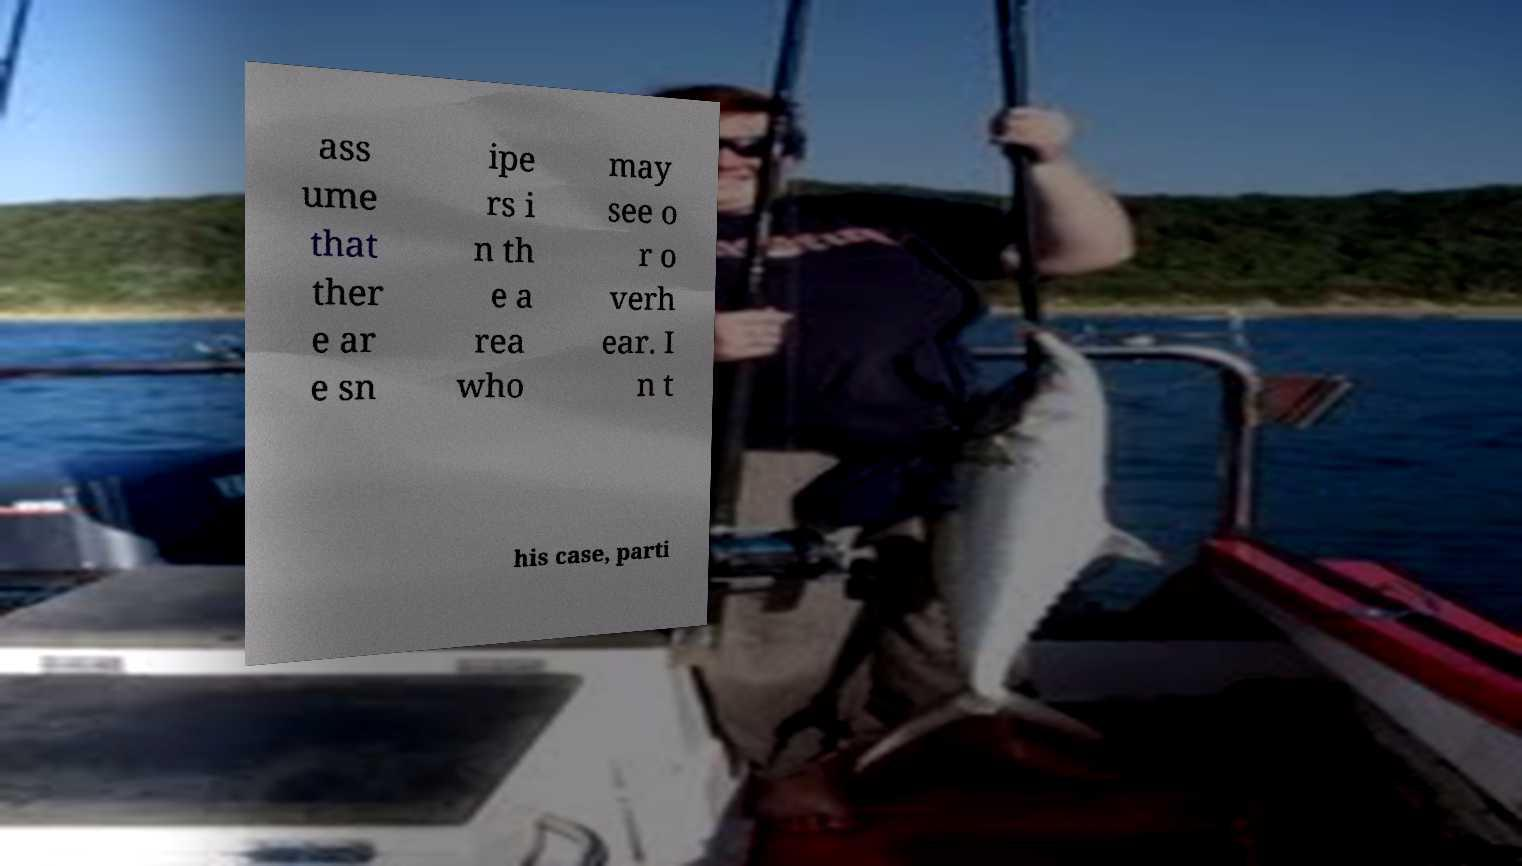I need the written content from this picture converted into text. Can you do that? ass ume that ther e ar e sn ipe rs i n th e a rea who may see o r o verh ear. I n t his case, parti 